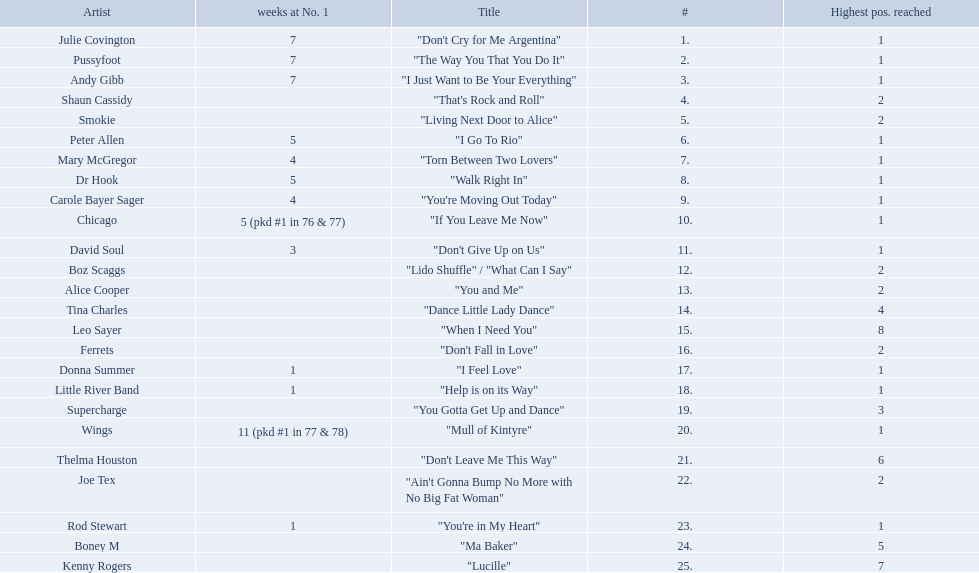Who had the one of the least weeks at number one? Rod Stewart. Who had no week at number one? Shaun Cassidy. Who had the highest number of weeks at number one? Wings. 